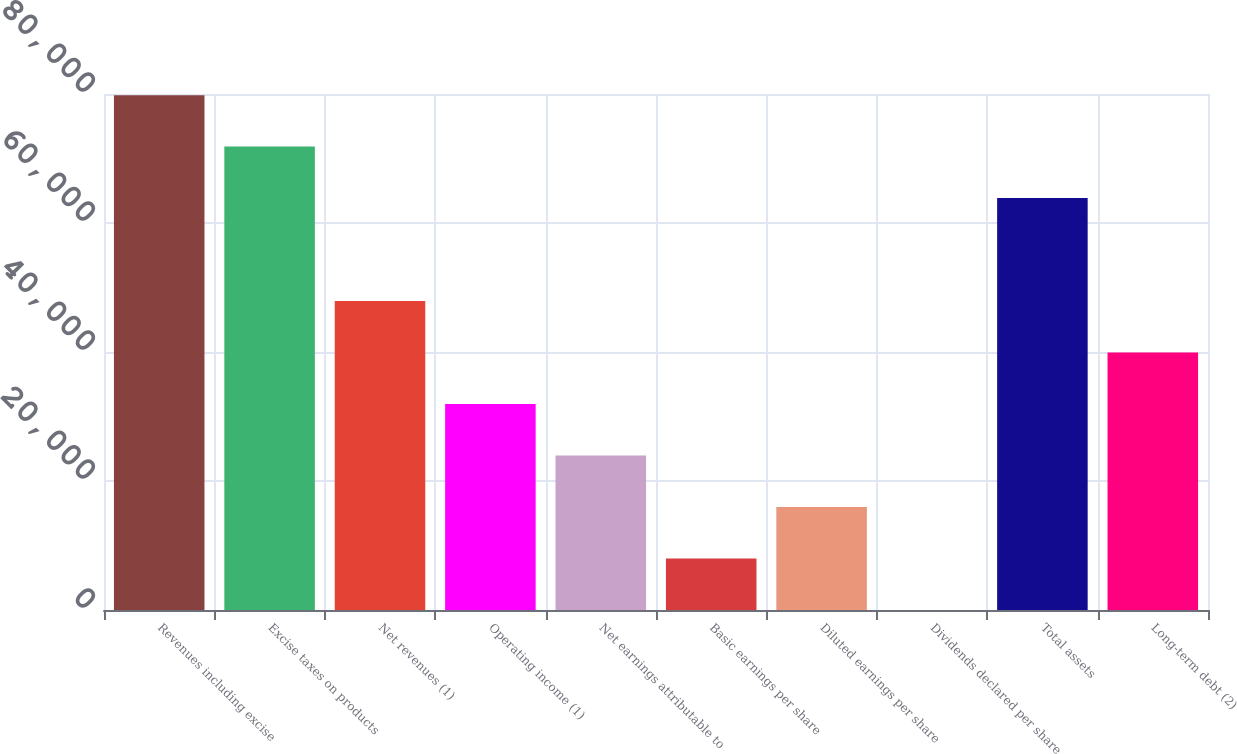Convert chart. <chart><loc_0><loc_0><loc_500><loc_500><bar_chart><fcel>Revenues including excise<fcel>Excise taxes on products<fcel>Net revenues (1)<fcel>Operating income (1)<fcel>Net earnings attributable to<fcel>Basic earnings per share<fcel>Diluted earnings per share<fcel>Dividends declared per share<fcel>Total assets<fcel>Long-term debt (2)<nl><fcel>79823<fcel>71841.1<fcel>47895.6<fcel>31931.9<fcel>23950<fcel>7986.34<fcel>15968.2<fcel>4.49<fcel>63859.3<fcel>39913.7<nl></chart> 